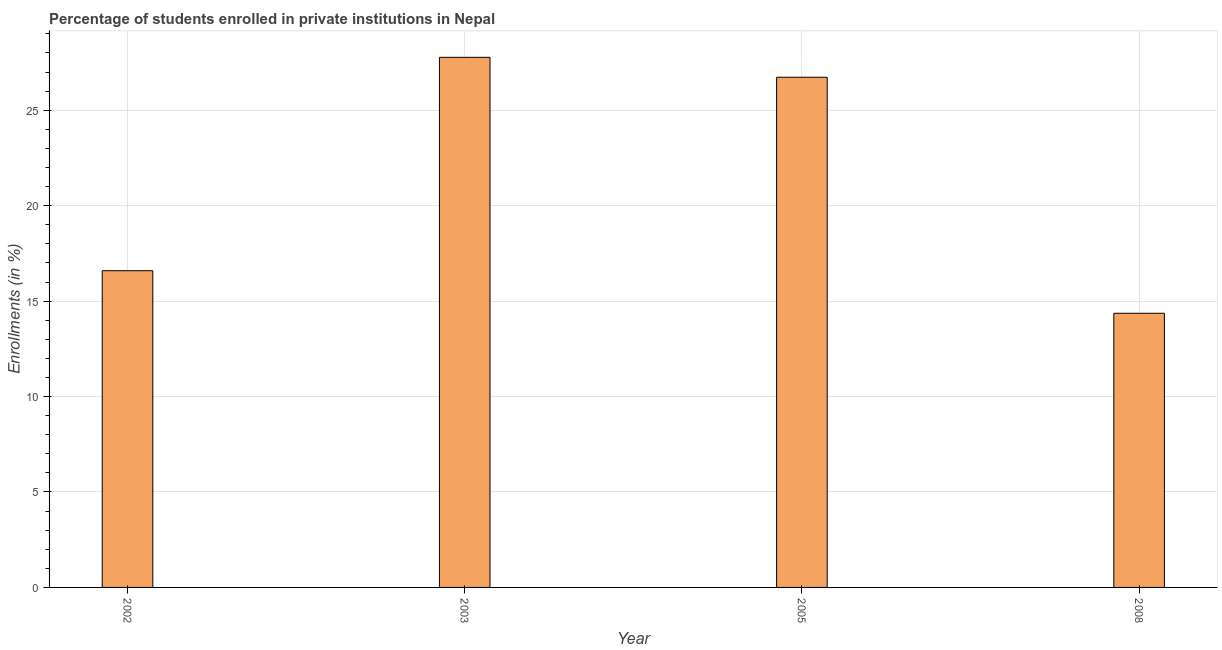What is the title of the graph?
Offer a very short reply. Percentage of students enrolled in private institutions in Nepal. What is the label or title of the X-axis?
Offer a very short reply. Year. What is the label or title of the Y-axis?
Offer a terse response. Enrollments (in %). What is the enrollments in private institutions in 2005?
Offer a terse response. 26.73. Across all years, what is the maximum enrollments in private institutions?
Your answer should be compact. 27.77. Across all years, what is the minimum enrollments in private institutions?
Your answer should be very brief. 14.36. What is the sum of the enrollments in private institutions?
Make the answer very short. 85.45. What is the difference between the enrollments in private institutions in 2002 and 2003?
Offer a very short reply. -11.18. What is the average enrollments in private institutions per year?
Give a very brief answer. 21.36. What is the median enrollments in private institutions?
Provide a succinct answer. 21.66. Do a majority of the years between 2003 and 2005 (inclusive) have enrollments in private institutions greater than 11 %?
Give a very brief answer. Yes. What is the ratio of the enrollments in private institutions in 2002 to that in 2005?
Offer a terse response. 0.62. Is the enrollments in private institutions in 2003 less than that in 2008?
Make the answer very short. No. Is the difference between the enrollments in private institutions in 2002 and 2005 greater than the difference between any two years?
Your answer should be very brief. No. What is the difference between the highest and the second highest enrollments in private institutions?
Your answer should be very brief. 1.04. Is the sum of the enrollments in private institutions in 2002 and 2008 greater than the maximum enrollments in private institutions across all years?
Provide a succinct answer. Yes. What is the difference between the highest and the lowest enrollments in private institutions?
Provide a short and direct response. 13.41. Are all the bars in the graph horizontal?
Make the answer very short. No. How many years are there in the graph?
Ensure brevity in your answer.  4. What is the Enrollments (in %) of 2002?
Provide a succinct answer. 16.59. What is the Enrollments (in %) of 2003?
Provide a succinct answer. 27.77. What is the Enrollments (in %) of 2005?
Ensure brevity in your answer.  26.73. What is the Enrollments (in %) of 2008?
Offer a terse response. 14.36. What is the difference between the Enrollments (in %) in 2002 and 2003?
Give a very brief answer. -11.18. What is the difference between the Enrollments (in %) in 2002 and 2005?
Provide a succinct answer. -10.14. What is the difference between the Enrollments (in %) in 2002 and 2008?
Provide a short and direct response. 2.23. What is the difference between the Enrollments (in %) in 2003 and 2005?
Provide a short and direct response. 1.04. What is the difference between the Enrollments (in %) in 2003 and 2008?
Your answer should be very brief. 13.41. What is the difference between the Enrollments (in %) in 2005 and 2008?
Your answer should be compact. 12.37. What is the ratio of the Enrollments (in %) in 2002 to that in 2003?
Your answer should be compact. 0.6. What is the ratio of the Enrollments (in %) in 2002 to that in 2005?
Keep it short and to the point. 0.62. What is the ratio of the Enrollments (in %) in 2002 to that in 2008?
Your answer should be compact. 1.16. What is the ratio of the Enrollments (in %) in 2003 to that in 2005?
Make the answer very short. 1.04. What is the ratio of the Enrollments (in %) in 2003 to that in 2008?
Your answer should be compact. 1.93. What is the ratio of the Enrollments (in %) in 2005 to that in 2008?
Offer a terse response. 1.86. 